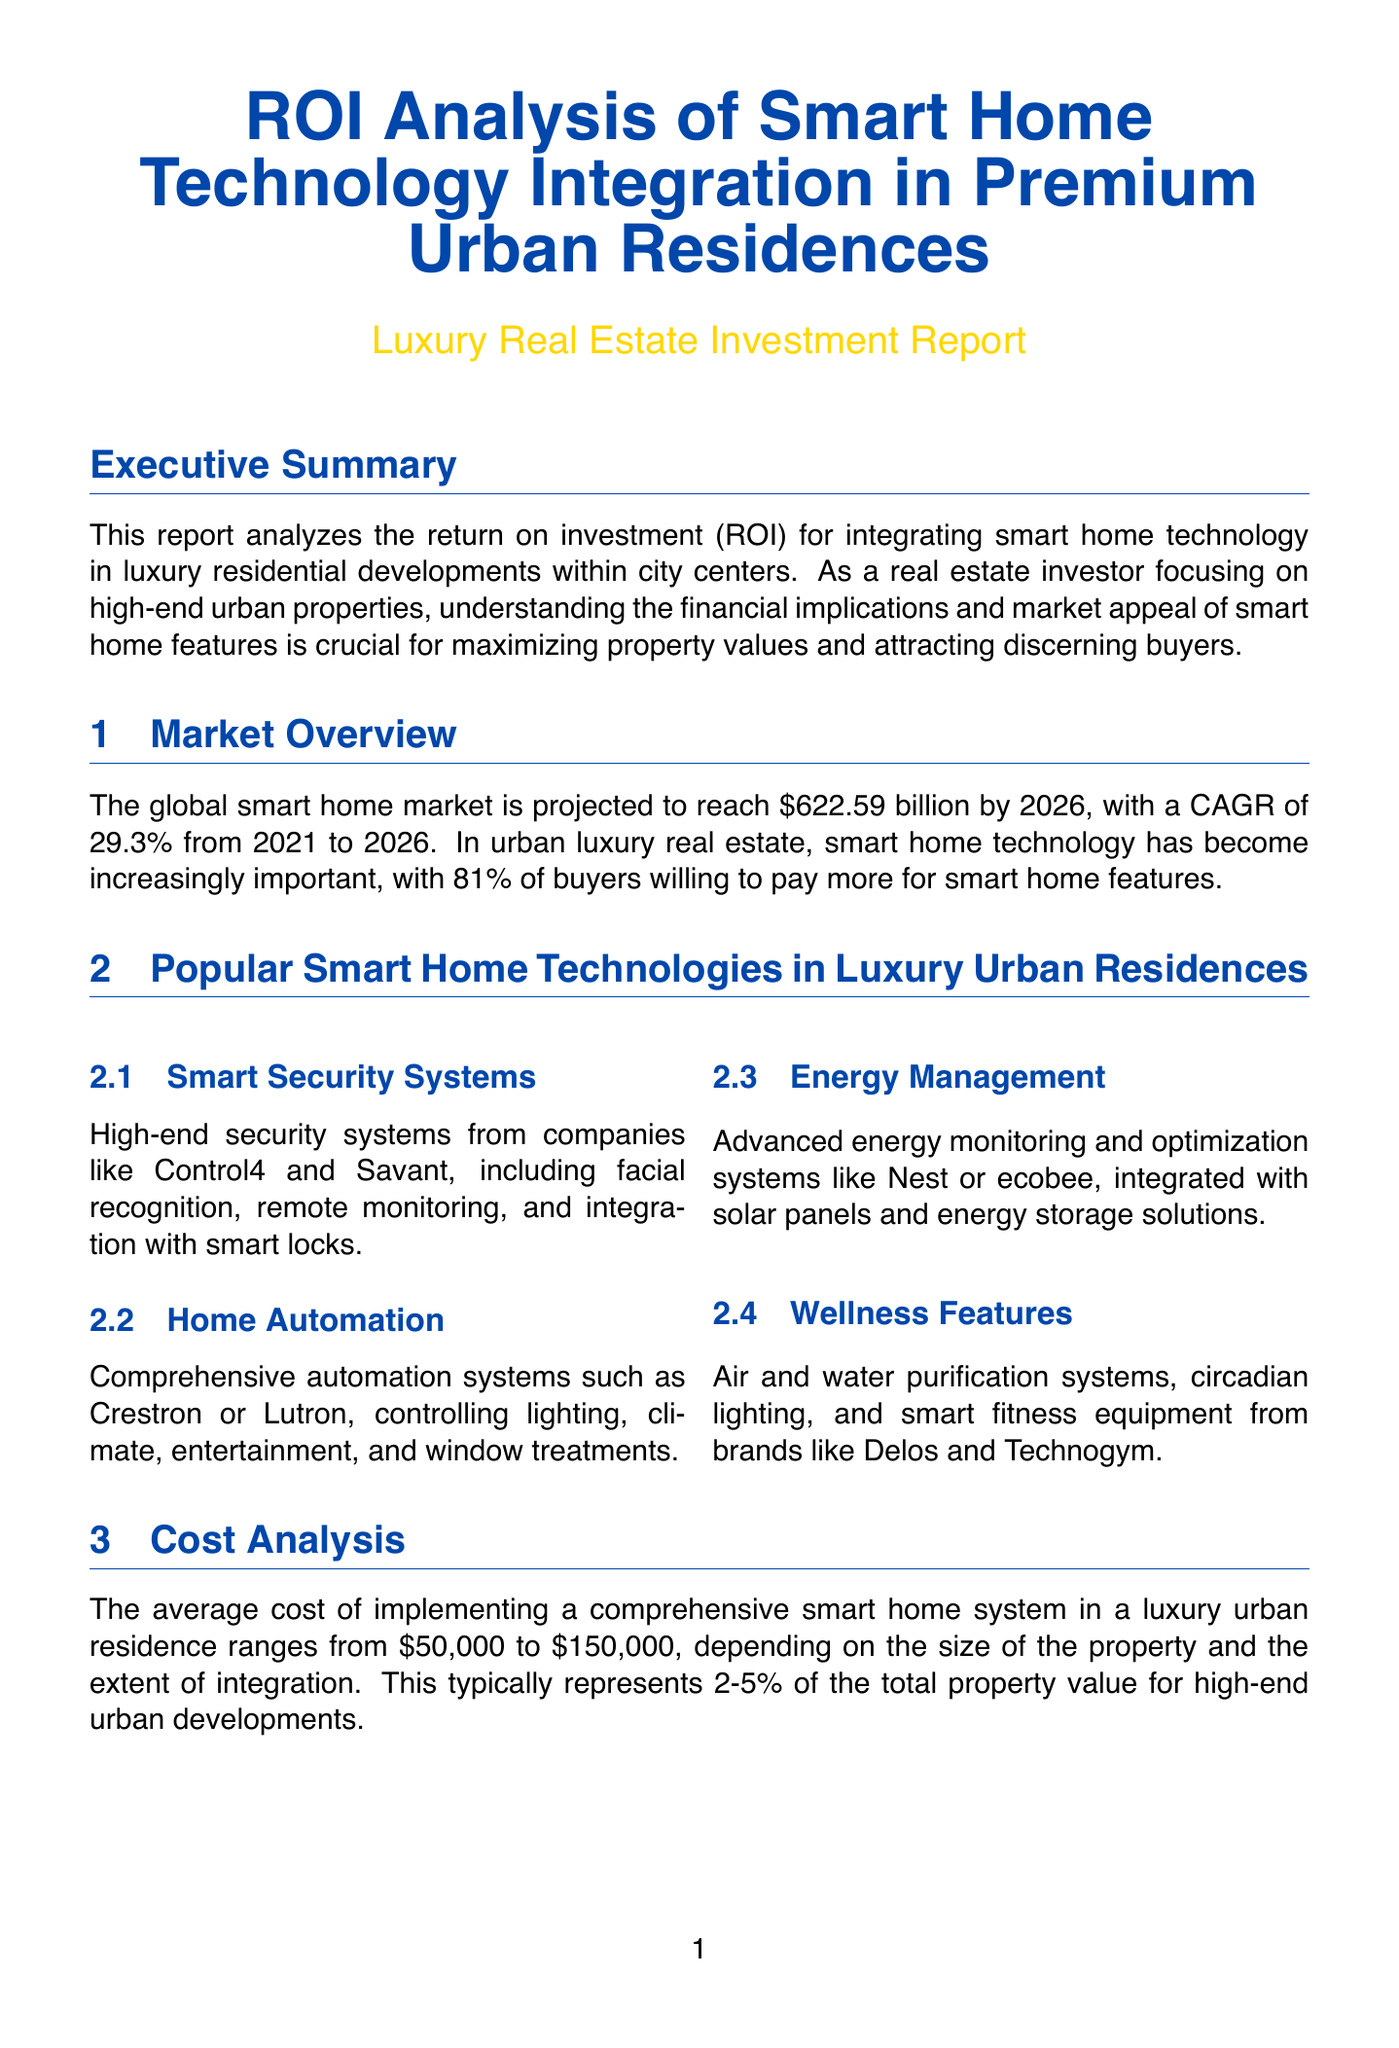What is the projected global smart home market value by 2026? The projected value is mentioned in the market overview section of the document as $622.59 billion.
Answer: $622.59 billion What is the average cost of implementing smart home systems? The cost analysis section specifies that the average cost ranges from $50,000 to $150,000 depending on various factors.
Answer: $50,000 to $150,000 How much faster do smart homes sell compared to non-smart properties? The document states that properties with integrated smart home technology tend to sell 20-30% faster, according to the ROI factors section.
Answer: 20-30% What percentage of buyers are willing to pay more for smart home features? This is highlighted in the market overview section where it states that 81% of buyers are willing to pay more.
Answer: 81% Which case study reports a 4.5% increase in sales prices? The case studies section identifies One57, New York City, as the example that experienced this increase.
Answer: One57, New York City What is the range of property value increase attributed to smart home features? The ROI factors subsection explains that smart home features can increase property values by 3-5%.
Answer: 3-5% What is the potential premium buyers are willing to pay for smart home features? The ROI factors subsection specifies that buyers are willing to pay a 3-7% premium for these features.
Answer: 3-7% What future technology is expected to enhance smart homes further? The future trends section mentions AI-powered predictive maintenance as one of the emerging technologies.
Answer: AI-powered predictive maintenance What percentage of the total property value does smart home technology implementation typically represent? The cost analysis section indicates that this implementation generally represents 2-5% of the total property value.
Answer: 2-5% 